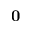<formula> <loc_0><loc_0><loc_500><loc_500>0</formula> 